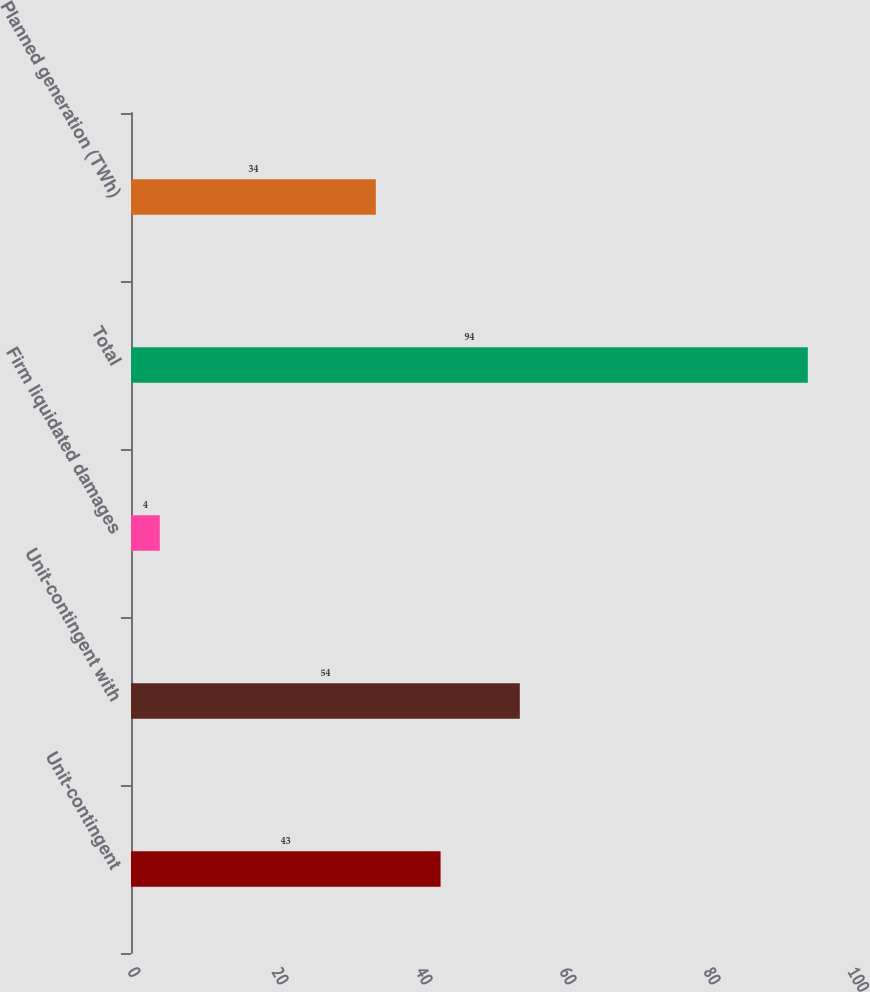Convert chart. <chart><loc_0><loc_0><loc_500><loc_500><bar_chart><fcel>Unit-contingent<fcel>Unit-contingent with<fcel>Firm liquidated damages<fcel>Total<fcel>Planned generation (TWh)<nl><fcel>43<fcel>54<fcel>4<fcel>94<fcel>34<nl></chart> 